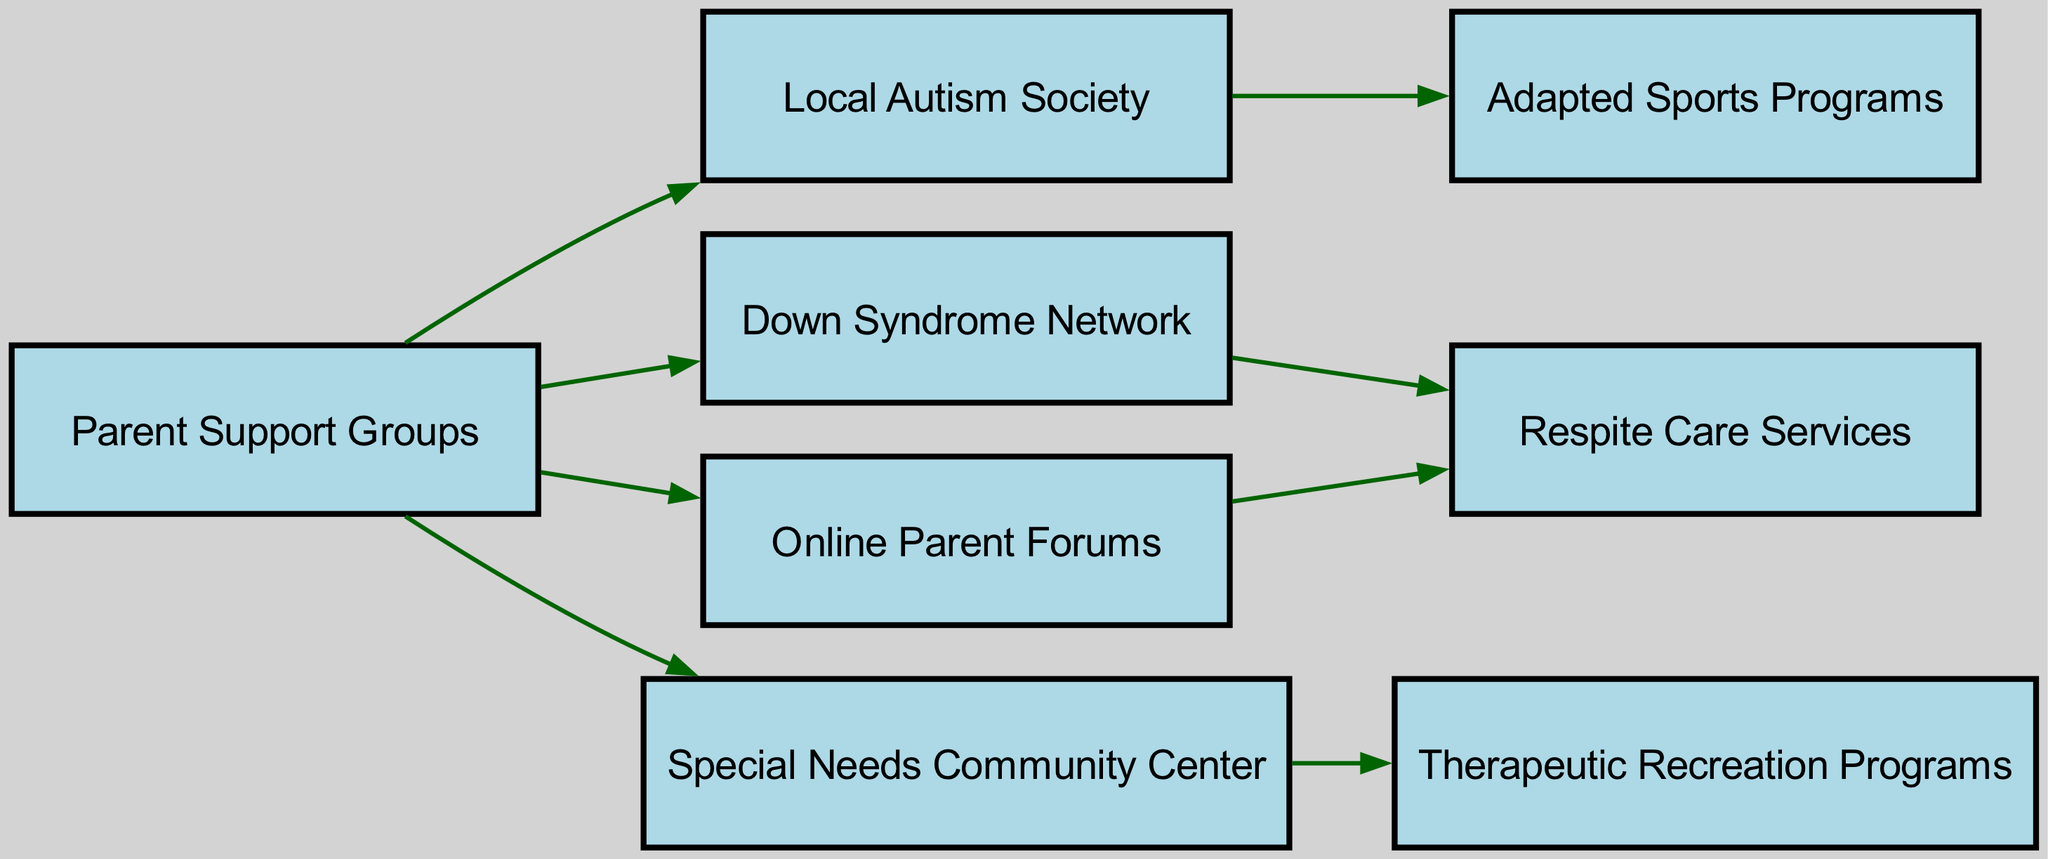What nodes are connected to the Parent Support Groups? To find the nodes connected to "Parent Support Groups," we look at the edges emanating from it. The connected nodes are "Local Autism Society," "Down Syndrome Network," "Special Needs Community Center," and "Online Parent Forums."
Answer: Local Autism Society, Down Syndrome Network, Special Needs Community Center, Online Parent Forums How many support groups are listed in the diagram? The diagram displays a total of eight nodes, and within those nodes, "Parent Support Groups," "Local Autism Society," "Down Syndrome Network," "Special Needs Community Center," and "Online Parent Forums" all refer to support or community activities. Counting these gives us five support groups.
Answer: 5 Which resource is directly connected to the Local Autism Society? To determine which resource is linked directly to "Local Autism Society," we can check the edges leading out from it. The only direct connection is to "Adapted Sports Programs."
Answer: Adapted Sports Programs What is the relationship between Online Parent Forums and Respite Care Services? To understand the relationship, we track the connections stemming from "Online Parent Forums." It connects to "Respite Care Services" through a direct edge. Thus, “Online Parent Forums” can facilitate information about "Respite Care Services."
Answer: Direct connection How many edges originate from the Special Needs Community Center? To answer this question, we inspect the edges starting from the node labeled "Special Needs Community Center." There is one edge leading to "Therapeutic Recreation Programs." Therefore, only one edge originates from it.
Answer: 1 